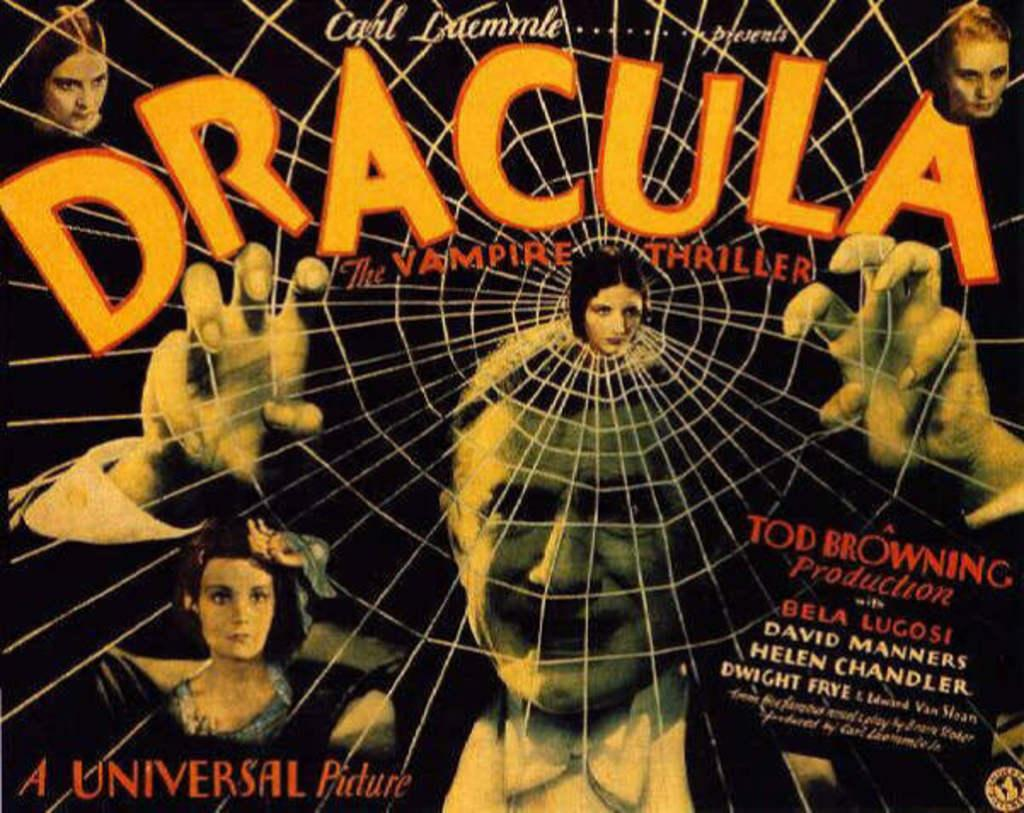<image>
Give a short and clear explanation of the subsequent image. A picture of a broadway production of Dracula. 